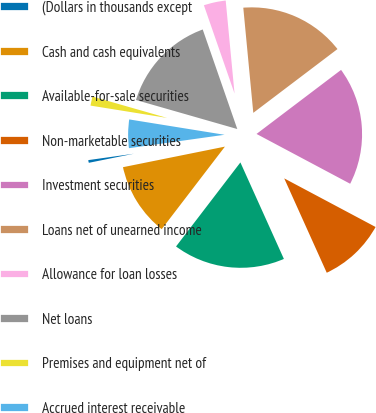<chart> <loc_0><loc_0><loc_500><loc_500><pie_chart><fcel>(Dollars in thousands except<fcel>Cash and cash equivalents<fcel>Available-for-sale securities<fcel>Non-marketable securities<fcel>Investment securities<fcel>Loans net of unearned income<fcel>Allowance for loan losses<fcel>Net loans<fcel>Premises and equipment net of<fcel>Accrued interest receivable<nl><fcel>0.95%<fcel>11.43%<fcel>17.14%<fcel>10.48%<fcel>18.1%<fcel>16.19%<fcel>3.81%<fcel>15.24%<fcel>1.9%<fcel>4.76%<nl></chart> 